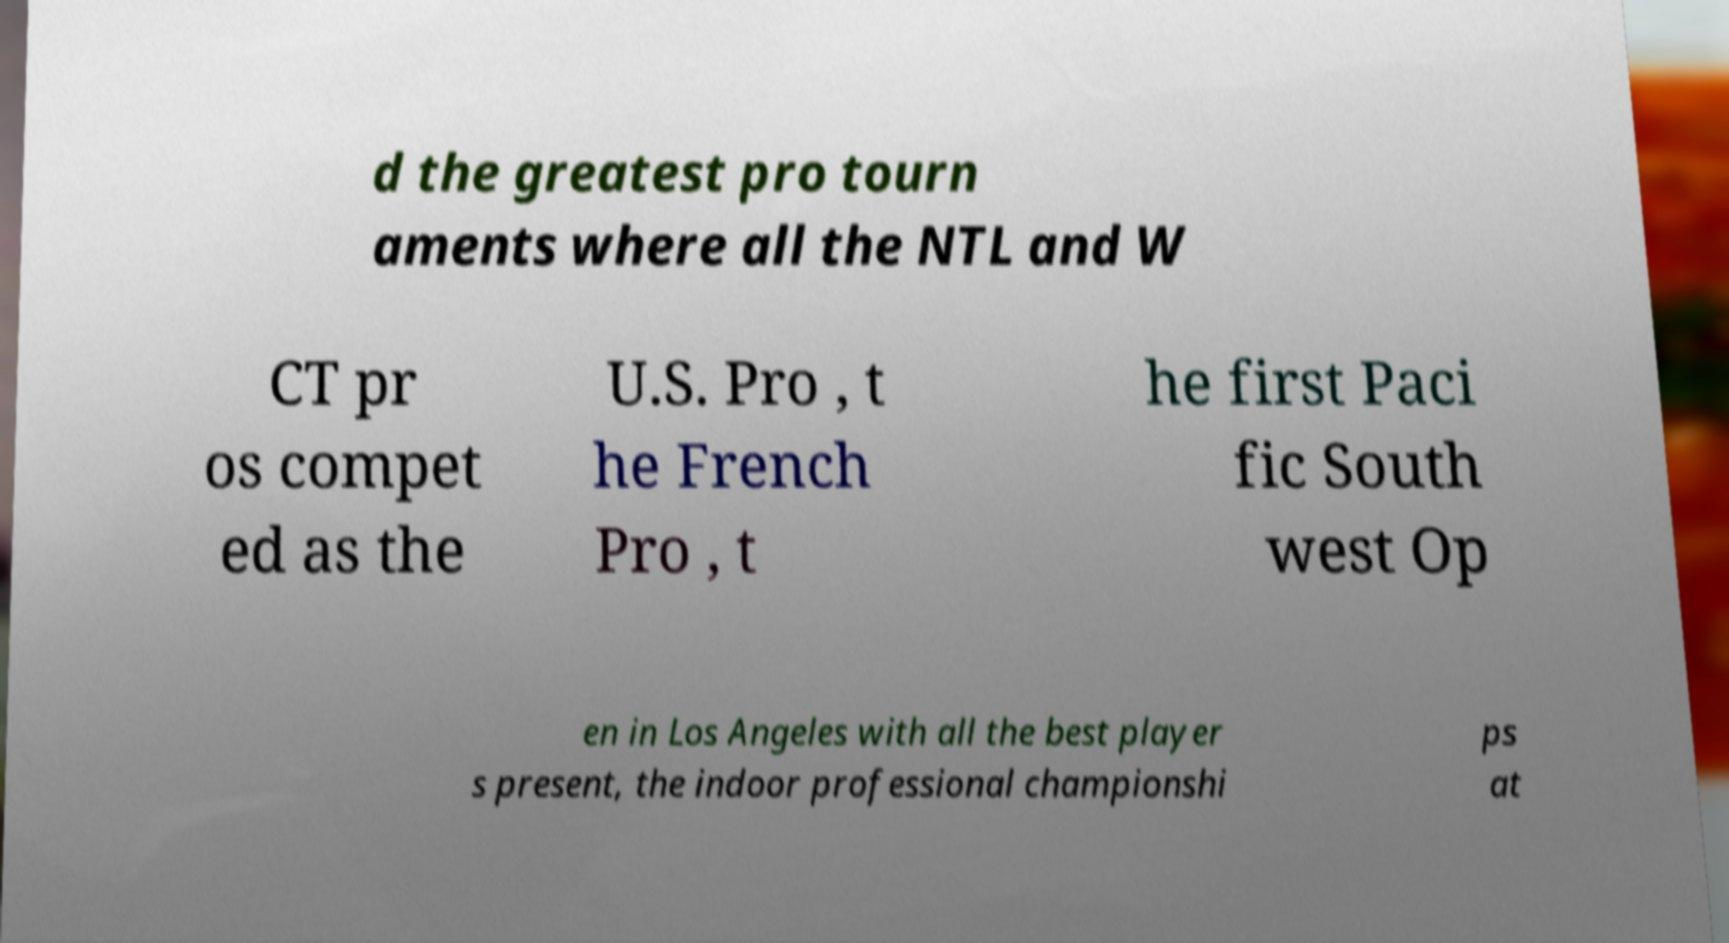Can you read and provide the text displayed in the image?This photo seems to have some interesting text. Can you extract and type it out for me? d the greatest pro tourn aments where all the NTL and W CT pr os compet ed as the U.S. Pro , t he French Pro , t he first Paci fic South west Op en in Los Angeles with all the best player s present, the indoor professional championshi ps at 